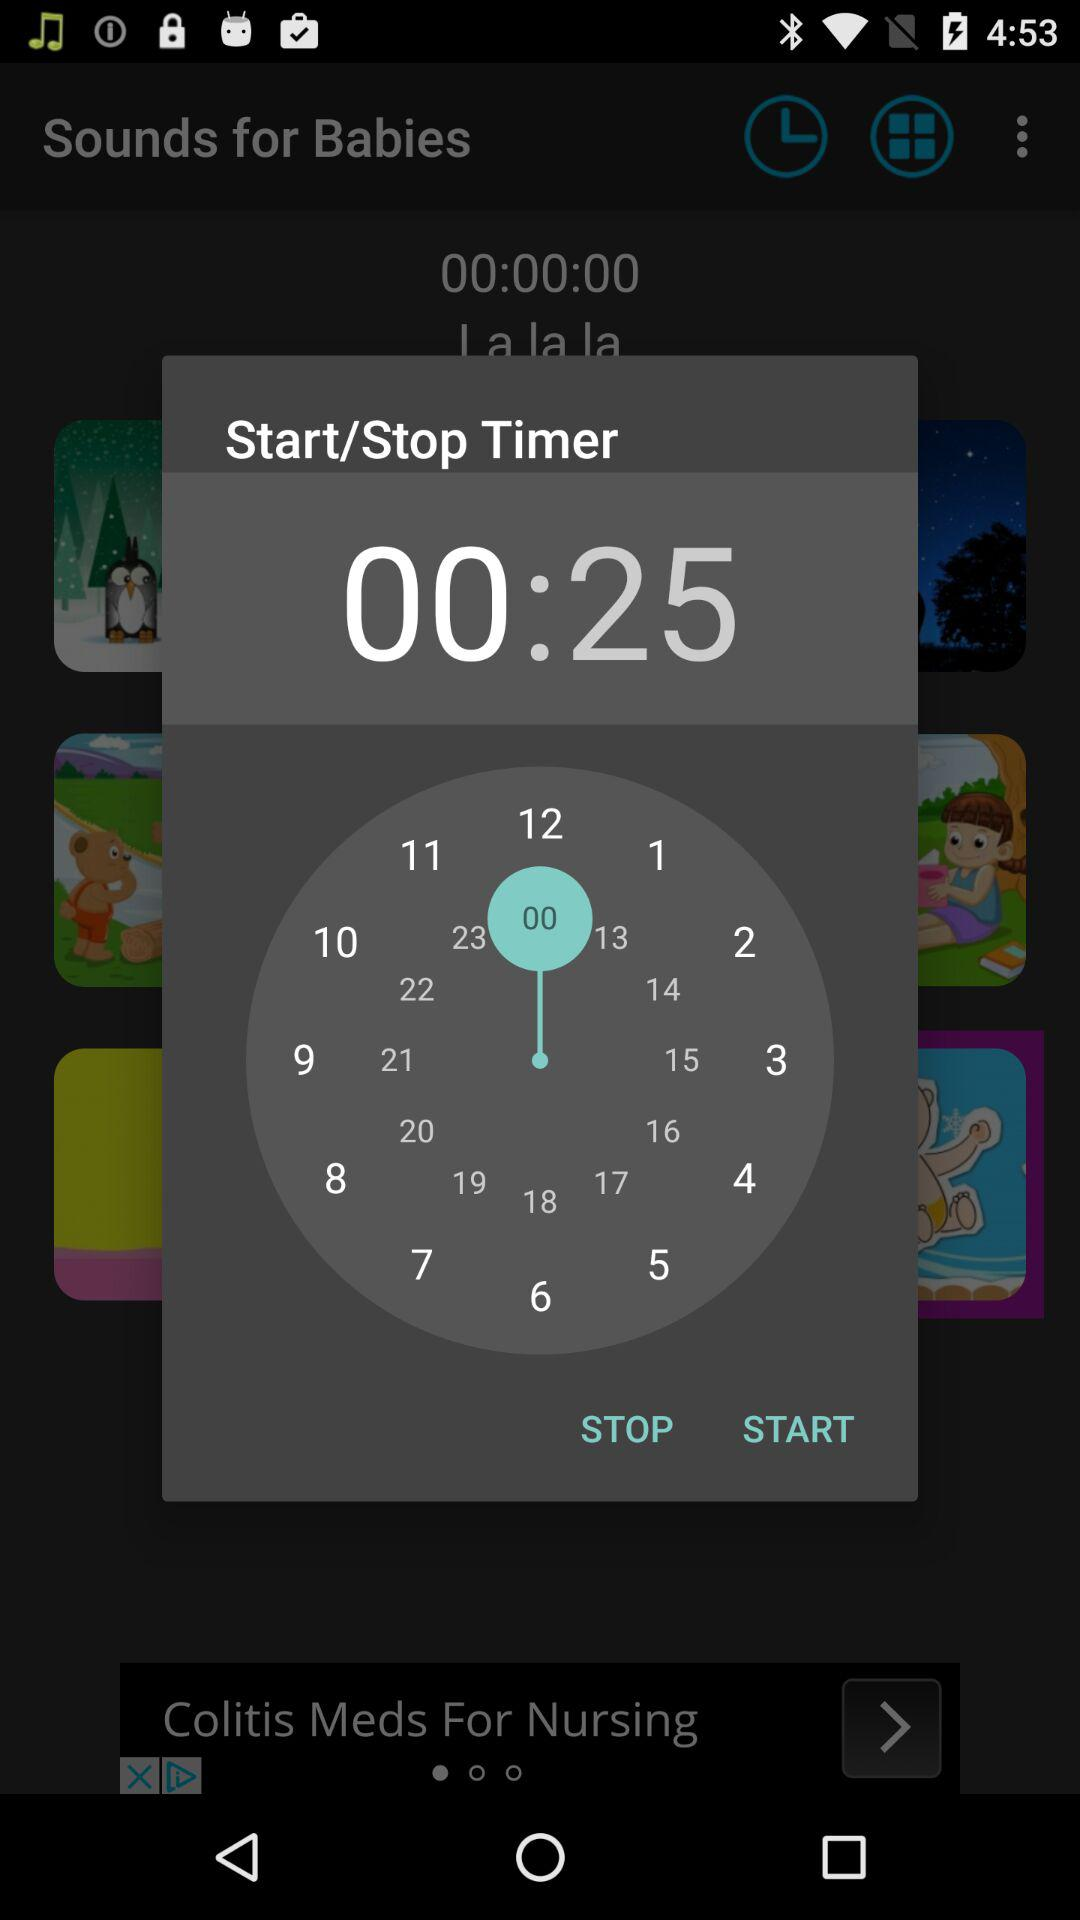What is the mentioned time? The mentioned time is 00:25. 